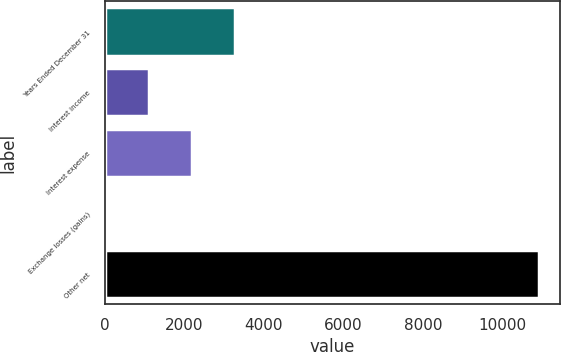<chart> <loc_0><loc_0><loc_500><loc_500><bar_chart><fcel>Years Ended December 31<fcel>Interest income<fcel>Interest expense<fcel>Exchange losses (gains)<fcel>Other net<nl><fcel>3280.2<fcel>1101.4<fcel>2190.8<fcel>12<fcel>10906<nl></chart> 